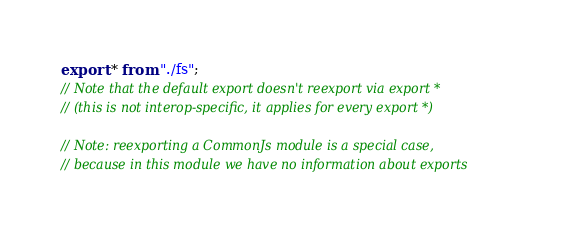<code> <loc_0><loc_0><loc_500><loc_500><_JavaScript_>export * from "./fs";
// Note that the default export doesn't reexport via export *
// (this is not interop-specific, it applies for every export *)

// Note: reexporting a CommonJs module is a special case,
// because in this module we have no information about exports
</code> 